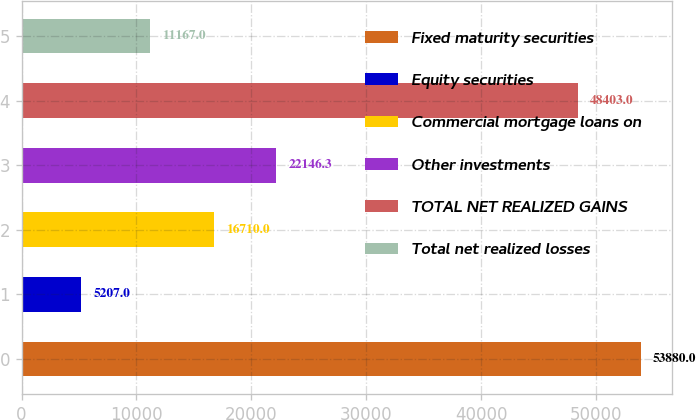<chart> <loc_0><loc_0><loc_500><loc_500><bar_chart><fcel>Fixed maturity securities<fcel>Equity securities<fcel>Commercial mortgage loans on<fcel>Other investments<fcel>TOTAL NET REALIZED GAINS<fcel>Total net realized losses<nl><fcel>53880<fcel>5207<fcel>16710<fcel>22146.3<fcel>48403<fcel>11167<nl></chart> 